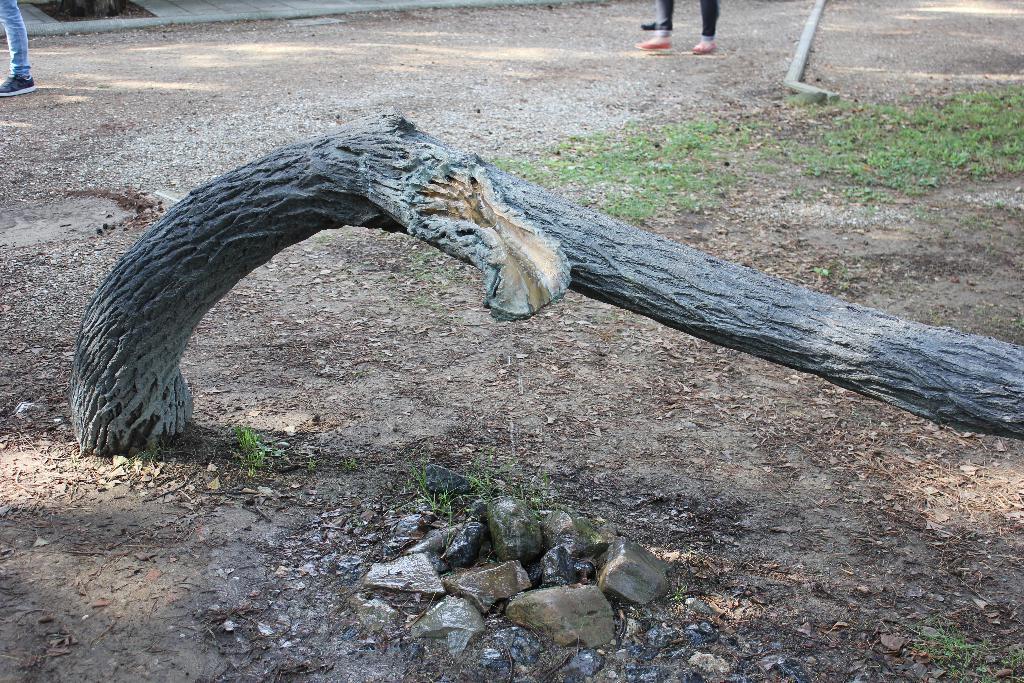In one or two sentences, can you explain what this image depicts? In this image I can see a trunk, background I can see few persons standing and I can see grass in green color. 